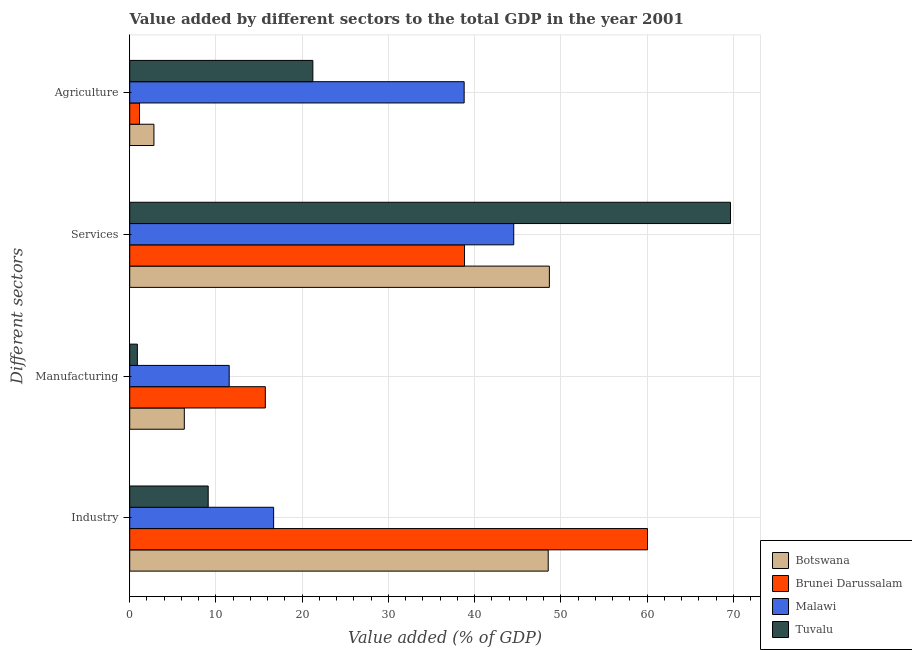How many different coloured bars are there?
Offer a very short reply. 4. How many groups of bars are there?
Ensure brevity in your answer.  4. What is the label of the 1st group of bars from the top?
Offer a very short reply. Agriculture. What is the value added by industrial sector in Tuvalu?
Your answer should be compact. 9.1. Across all countries, what is the maximum value added by agricultural sector?
Your answer should be compact. 38.78. Across all countries, what is the minimum value added by manufacturing sector?
Ensure brevity in your answer.  0.89. In which country was the value added by agricultural sector maximum?
Offer a very short reply. Malawi. In which country was the value added by manufacturing sector minimum?
Keep it short and to the point. Tuvalu. What is the total value added by services sector in the graph?
Keep it short and to the point. 201.68. What is the difference between the value added by services sector in Tuvalu and that in Brunei Darussalam?
Ensure brevity in your answer.  30.84. What is the difference between the value added by services sector in Botswana and the value added by agricultural sector in Brunei Darussalam?
Offer a very short reply. 47.53. What is the average value added by services sector per country?
Offer a terse response. 50.42. What is the difference between the value added by manufacturing sector and value added by services sector in Brunei Darussalam?
Your answer should be compact. -23.1. What is the ratio of the value added by services sector in Malawi to that in Tuvalu?
Offer a very short reply. 0.64. Is the difference between the value added by agricultural sector in Malawi and Tuvalu greater than the difference between the value added by industrial sector in Malawi and Tuvalu?
Make the answer very short. Yes. What is the difference between the highest and the second highest value added by manufacturing sector?
Your answer should be very brief. 4.19. What is the difference between the highest and the lowest value added by agricultural sector?
Provide a succinct answer. 37.65. In how many countries, is the value added by industrial sector greater than the average value added by industrial sector taken over all countries?
Give a very brief answer. 2. What does the 1st bar from the top in Industry represents?
Give a very brief answer. Tuvalu. What does the 1st bar from the bottom in Agriculture represents?
Give a very brief answer. Botswana. How many countries are there in the graph?
Provide a short and direct response. 4. Are the values on the major ticks of X-axis written in scientific E-notation?
Your answer should be very brief. No. Where does the legend appear in the graph?
Your answer should be compact. Bottom right. How many legend labels are there?
Your answer should be very brief. 4. How are the legend labels stacked?
Your response must be concise. Vertical. What is the title of the graph?
Keep it short and to the point. Value added by different sectors to the total GDP in the year 2001. What is the label or title of the X-axis?
Provide a succinct answer. Value added (% of GDP). What is the label or title of the Y-axis?
Your response must be concise. Different sectors. What is the Value added (% of GDP) in Botswana in Industry?
Make the answer very short. 48.53. What is the Value added (% of GDP) of Brunei Darussalam in Industry?
Provide a succinct answer. 60.04. What is the Value added (% of GDP) in Malawi in Industry?
Make the answer very short. 16.69. What is the Value added (% of GDP) in Tuvalu in Industry?
Make the answer very short. 9.1. What is the Value added (% of GDP) of Botswana in Manufacturing?
Your response must be concise. 6.33. What is the Value added (% of GDP) of Brunei Darussalam in Manufacturing?
Make the answer very short. 15.73. What is the Value added (% of GDP) in Malawi in Manufacturing?
Offer a very short reply. 11.53. What is the Value added (% of GDP) in Tuvalu in Manufacturing?
Give a very brief answer. 0.89. What is the Value added (% of GDP) in Botswana in Services?
Your answer should be very brief. 48.66. What is the Value added (% of GDP) of Brunei Darussalam in Services?
Give a very brief answer. 38.82. What is the Value added (% of GDP) in Malawi in Services?
Your response must be concise. 44.53. What is the Value added (% of GDP) of Tuvalu in Services?
Offer a terse response. 69.66. What is the Value added (% of GDP) of Botswana in Agriculture?
Make the answer very short. 2.81. What is the Value added (% of GDP) of Brunei Darussalam in Agriculture?
Offer a terse response. 1.13. What is the Value added (% of GDP) of Malawi in Agriculture?
Offer a terse response. 38.78. What is the Value added (% of GDP) of Tuvalu in Agriculture?
Provide a short and direct response. 21.24. Across all Different sectors, what is the maximum Value added (% of GDP) of Botswana?
Make the answer very short. 48.66. Across all Different sectors, what is the maximum Value added (% of GDP) in Brunei Darussalam?
Ensure brevity in your answer.  60.04. Across all Different sectors, what is the maximum Value added (% of GDP) in Malawi?
Your answer should be very brief. 44.53. Across all Different sectors, what is the maximum Value added (% of GDP) of Tuvalu?
Make the answer very short. 69.66. Across all Different sectors, what is the minimum Value added (% of GDP) of Botswana?
Your response must be concise. 2.81. Across all Different sectors, what is the minimum Value added (% of GDP) in Brunei Darussalam?
Ensure brevity in your answer.  1.13. Across all Different sectors, what is the minimum Value added (% of GDP) of Malawi?
Your response must be concise. 11.53. Across all Different sectors, what is the minimum Value added (% of GDP) in Tuvalu?
Your response must be concise. 0.89. What is the total Value added (% of GDP) in Botswana in the graph?
Provide a succinct answer. 106.33. What is the total Value added (% of GDP) of Brunei Darussalam in the graph?
Offer a terse response. 115.73. What is the total Value added (% of GDP) of Malawi in the graph?
Ensure brevity in your answer.  111.53. What is the total Value added (% of GDP) of Tuvalu in the graph?
Keep it short and to the point. 100.89. What is the difference between the Value added (% of GDP) in Botswana in Industry and that in Manufacturing?
Keep it short and to the point. 42.2. What is the difference between the Value added (% of GDP) of Brunei Darussalam in Industry and that in Manufacturing?
Your response must be concise. 44.32. What is the difference between the Value added (% of GDP) of Malawi in Industry and that in Manufacturing?
Make the answer very short. 5.15. What is the difference between the Value added (% of GDP) of Tuvalu in Industry and that in Manufacturing?
Offer a terse response. 8.21. What is the difference between the Value added (% of GDP) of Botswana in Industry and that in Services?
Give a very brief answer. -0.13. What is the difference between the Value added (% of GDP) of Brunei Darussalam in Industry and that in Services?
Keep it short and to the point. 21.22. What is the difference between the Value added (% of GDP) of Malawi in Industry and that in Services?
Provide a short and direct response. -27.84. What is the difference between the Value added (% of GDP) of Tuvalu in Industry and that in Services?
Make the answer very short. -60.56. What is the difference between the Value added (% of GDP) of Botswana in Industry and that in Agriculture?
Your response must be concise. 45.72. What is the difference between the Value added (% of GDP) of Brunei Darussalam in Industry and that in Agriculture?
Give a very brief answer. 58.91. What is the difference between the Value added (% of GDP) in Malawi in Industry and that in Agriculture?
Offer a very short reply. -22.09. What is the difference between the Value added (% of GDP) of Tuvalu in Industry and that in Agriculture?
Give a very brief answer. -12.14. What is the difference between the Value added (% of GDP) in Botswana in Manufacturing and that in Services?
Your response must be concise. -42.33. What is the difference between the Value added (% of GDP) of Brunei Darussalam in Manufacturing and that in Services?
Your answer should be compact. -23.1. What is the difference between the Value added (% of GDP) in Malawi in Manufacturing and that in Services?
Make the answer very short. -33. What is the difference between the Value added (% of GDP) in Tuvalu in Manufacturing and that in Services?
Your response must be concise. -68.78. What is the difference between the Value added (% of GDP) of Botswana in Manufacturing and that in Agriculture?
Provide a succinct answer. 3.52. What is the difference between the Value added (% of GDP) in Brunei Darussalam in Manufacturing and that in Agriculture?
Offer a very short reply. 14.59. What is the difference between the Value added (% of GDP) of Malawi in Manufacturing and that in Agriculture?
Your answer should be compact. -27.25. What is the difference between the Value added (% of GDP) of Tuvalu in Manufacturing and that in Agriculture?
Provide a short and direct response. -20.35. What is the difference between the Value added (% of GDP) of Botswana in Services and that in Agriculture?
Ensure brevity in your answer.  45.86. What is the difference between the Value added (% of GDP) of Brunei Darussalam in Services and that in Agriculture?
Ensure brevity in your answer.  37.69. What is the difference between the Value added (% of GDP) of Malawi in Services and that in Agriculture?
Give a very brief answer. 5.75. What is the difference between the Value added (% of GDP) in Tuvalu in Services and that in Agriculture?
Your answer should be very brief. 48.43. What is the difference between the Value added (% of GDP) in Botswana in Industry and the Value added (% of GDP) in Brunei Darussalam in Manufacturing?
Ensure brevity in your answer.  32.8. What is the difference between the Value added (% of GDP) of Botswana in Industry and the Value added (% of GDP) of Malawi in Manufacturing?
Your response must be concise. 36.99. What is the difference between the Value added (% of GDP) of Botswana in Industry and the Value added (% of GDP) of Tuvalu in Manufacturing?
Give a very brief answer. 47.64. What is the difference between the Value added (% of GDP) of Brunei Darussalam in Industry and the Value added (% of GDP) of Malawi in Manufacturing?
Your answer should be very brief. 48.51. What is the difference between the Value added (% of GDP) in Brunei Darussalam in Industry and the Value added (% of GDP) in Tuvalu in Manufacturing?
Offer a very short reply. 59.16. What is the difference between the Value added (% of GDP) in Malawi in Industry and the Value added (% of GDP) in Tuvalu in Manufacturing?
Offer a terse response. 15.8. What is the difference between the Value added (% of GDP) of Botswana in Industry and the Value added (% of GDP) of Brunei Darussalam in Services?
Make the answer very short. 9.71. What is the difference between the Value added (% of GDP) in Botswana in Industry and the Value added (% of GDP) in Malawi in Services?
Give a very brief answer. 4. What is the difference between the Value added (% of GDP) of Botswana in Industry and the Value added (% of GDP) of Tuvalu in Services?
Keep it short and to the point. -21.14. What is the difference between the Value added (% of GDP) of Brunei Darussalam in Industry and the Value added (% of GDP) of Malawi in Services?
Your response must be concise. 15.51. What is the difference between the Value added (% of GDP) in Brunei Darussalam in Industry and the Value added (% of GDP) in Tuvalu in Services?
Provide a short and direct response. -9.62. What is the difference between the Value added (% of GDP) in Malawi in Industry and the Value added (% of GDP) in Tuvalu in Services?
Keep it short and to the point. -52.98. What is the difference between the Value added (% of GDP) of Botswana in Industry and the Value added (% of GDP) of Brunei Darussalam in Agriculture?
Your response must be concise. 47.39. What is the difference between the Value added (% of GDP) of Botswana in Industry and the Value added (% of GDP) of Malawi in Agriculture?
Offer a very short reply. 9.75. What is the difference between the Value added (% of GDP) of Botswana in Industry and the Value added (% of GDP) of Tuvalu in Agriculture?
Give a very brief answer. 27.29. What is the difference between the Value added (% of GDP) of Brunei Darussalam in Industry and the Value added (% of GDP) of Malawi in Agriculture?
Provide a short and direct response. 21.26. What is the difference between the Value added (% of GDP) of Brunei Darussalam in Industry and the Value added (% of GDP) of Tuvalu in Agriculture?
Your answer should be very brief. 38.81. What is the difference between the Value added (% of GDP) of Malawi in Industry and the Value added (% of GDP) of Tuvalu in Agriculture?
Provide a short and direct response. -4.55. What is the difference between the Value added (% of GDP) of Botswana in Manufacturing and the Value added (% of GDP) of Brunei Darussalam in Services?
Make the answer very short. -32.49. What is the difference between the Value added (% of GDP) in Botswana in Manufacturing and the Value added (% of GDP) in Malawi in Services?
Make the answer very short. -38.2. What is the difference between the Value added (% of GDP) in Botswana in Manufacturing and the Value added (% of GDP) in Tuvalu in Services?
Provide a succinct answer. -63.33. What is the difference between the Value added (% of GDP) of Brunei Darussalam in Manufacturing and the Value added (% of GDP) of Malawi in Services?
Provide a short and direct response. -28.8. What is the difference between the Value added (% of GDP) of Brunei Darussalam in Manufacturing and the Value added (% of GDP) of Tuvalu in Services?
Give a very brief answer. -53.94. What is the difference between the Value added (% of GDP) in Malawi in Manufacturing and the Value added (% of GDP) in Tuvalu in Services?
Keep it short and to the point. -58.13. What is the difference between the Value added (% of GDP) of Botswana in Manufacturing and the Value added (% of GDP) of Brunei Darussalam in Agriculture?
Ensure brevity in your answer.  5.2. What is the difference between the Value added (% of GDP) in Botswana in Manufacturing and the Value added (% of GDP) in Malawi in Agriculture?
Make the answer very short. -32.45. What is the difference between the Value added (% of GDP) of Botswana in Manufacturing and the Value added (% of GDP) of Tuvalu in Agriculture?
Make the answer very short. -14.91. What is the difference between the Value added (% of GDP) of Brunei Darussalam in Manufacturing and the Value added (% of GDP) of Malawi in Agriculture?
Give a very brief answer. -23.06. What is the difference between the Value added (% of GDP) of Brunei Darussalam in Manufacturing and the Value added (% of GDP) of Tuvalu in Agriculture?
Provide a succinct answer. -5.51. What is the difference between the Value added (% of GDP) of Malawi in Manufacturing and the Value added (% of GDP) of Tuvalu in Agriculture?
Offer a very short reply. -9.7. What is the difference between the Value added (% of GDP) of Botswana in Services and the Value added (% of GDP) of Brunei Darussalam in Agriculture?
Provide a short and direct response. 47.53. What is the difference between the Value added (% of GDP) in Botswana in Services and the Value added (% of GDP) in Malawi in Agriculture?
Offer a terse response. 9.88. What is the difference between the Value added (% of GDP) of Botswana in Services and the Value added (% of GDP) of Tuvalu in Agriculture?
Keep it short and to the point. 27.43. What is the difference between the Value added (% of GDP) of Brunei Darussalam in Services and the Value added (% of GDP) of Malawi in Agriculture?
Provide a short and direct response. 0.04. What is the difference between the Value added (% of GDP) of Brunei Darussalam in Services and the Value added (% of GDP) of Tuvalu in Agriculture?
Provide a succinct answer. 17.59. What is the difference between the Value added (% of GDP) in Malawi in Services and the Value added (% of GDP) in Tuvalu in Agriculture?
Make the answer very short. 23.29. What is the average Value added (% of GDP) in Botswana per Different sectors?
Offer a terse response. 26.58. What is the average Value added (% of GDP) in Brunei Darussalam per Different sectors?
Your answer should be compact. 28.93. What is the average Value added (% of GDP) in Malawi per Different sectors?
Offer a very short reply. 27.88. What is the average Value added (% of GDP) of Tuvalu per Different sectors?
Ensure brevity in your answer.  25.22. What is the difference between the Value added (% of GDP) of Botswana and Value added (% of GDP) of Brunei Darussalam in Industry?
Your response must be concise. -11.51. What is the difference between the Value added (% of GDP) in Botswana and Value added (% of GDP) in Malawi in Industry?
Offer a very short reply. 31.84. What is the difference between the Value added (% of GDP) of Botswana and Value added (% of GDP) of Tuvalu in Industry?
Your answer should be very brief. 39.43. What is the difference between the Value added (% of GDP) in Brunei Darussalam and Value added (% of GDP) in Malawi in Industry?
Offer a terse response. 43.35. What is the difference between the Value added (% of GDP) of Brunei Darussalam and Value added (% of GDP) of Tuvalu in Industry?
Provide a succinct answer. 50.94. What is the difference between the Value added (% of GDP) of Malawi and Value added (% of GDP) of Tuvalu in Industry?
Your answer should be compact. 7.59. What is the difference between the Value added (% of GDP) in Botswana and Value added (% of GDP) in Brunei Darussalam in Manufacturing?
Your answer should be compact. -9.39. What is the difference between the Value added (% of GDP) in Botswana and Value added (% of GDP) in Malawi in Manufacturing?
Provide a succinct answer. -5.2. What is the difference between the Value added (% of GDP) of Botswana and Value added (% of GDP) of Tuvalu in Manufacturing?
Give a very brief answer. 5.45. What is the difference between the Value added (% of GDP) in Brunei Darussalam and Value added (% of GDP) in Malawi in Manufacturing?
Ensure brevity in your answer.  4.19. What is the difference between the Value added (% of GDP) in Brunei Darussalam and Value added (% of GDP) in Tuvalu in Manufacturing?
Ensure brevity in your answer.  14.84. What is the difference between the Value added (% of GDP) in Malawi and Value added (% of GDP) in Tuvalu in Manufacturing?
Ensure brevity in your answer.  10.65. What is the difference between the Value added (% of GDP) in Botswana and Value added (% of GDP) in Brunei Darussalam in Services?
Your response must be concise. 9.84. What is the difference between the Value added (% of GDP) in Botswana and Value added (% of GDP) in Malawi in Services?
Ensure brevity in your answer.  4.13. What is the difference between the Value added (% of GDP) of Botswana and Value added (% of GDP) of Tuvalu in Services?
Provide a short and direct response. -21. What is the difference between the Value added (% of GDP) in Brunei Darussalam and Value added (% of GDP) in Malawi in Services?
Make the answer very short. -5.71. What is the difference between the Value added (% of GDP) in Brunei Darussalam and Value added (% of GDP) in Tuvalu in Services?
Offer a terse response. -30.84. What is the difference between the Value added (% of GDP) of Malawi and Value added (% of GDP) of Tuvalu in Services?
Make the answer very short. -25.13. What is the difference between the Value added (% of GDP) in Botswana and Value added (% of GDP) in Brunei Darussalam in Agriculture?
Offer a terse response. 1.67. What is the difference between the Value added (% of GDP) in Botswana and Value added (% of GDP) in Malawi in Agriculture?
Offer a terse response. -35.97. What is the difference between the Value added (% of GDP) in Botswana and Value added (% of GDP) in Tuvalu in Agriculture?
Give a very brief answer. -18.43. What is the difference between the Value added (% of GDP) in Brunei Darussalam and Value added (% of GDP) in Malawi in Agriculture?
Your answer should be compact. -37.65. What is the difference between the Value added (% of GDP) in Brunei Darussalam and Value added (% of GDP) in Tuvalu in Agriculture?
Ensure brevity in your answer.  -20.1. What is the difference between the Value added (% of GDP) in Malawi and Value added (% of GDP) in Tuvalu in Agriculture?
Your answer should be very brief. 17.55. What is the ratio of the Value added (% of GDP) in Botswana in Industry to that in Manufacturing?
Ensure brevity in your answer.  7.67. What is the ratio of the Value added (% of GDP) of Brunei Darussalam in Industry to that in Manufacturing?
Your response must be concise. 3.82. What is the ratio of the Value added (% of GDP) in Malawi in Industry to that in Manufacturing?
Your response must be concise. 1.45. What is the ratio of the Value added (% of GDP) of Tuvalu in Industry to that in Manufacturing?
Ensure brevity in your answer.  10.28. What is the ratio of the Value added (% of GDP) in Brunei Darussalam in Industry to that in Services?
Give a very brief answer. 1.55. What is the ratio of the Value added (% of GDP) in Malawi in Industry to that in Services?
Your response must be concise. 0.37. What is the ratio of the Value added (% of GDP) in Tuvalu in Industry to that in Services?
Provide a succinct answer. 0.13. What is the ratio of the Value added (% of GDP) of Botswana in Industry to that in Agriculture?
Ensure brevity in your answer.  17.28. What is the ratio of the Value added (% of GDP) of Brunei Darussalam in Industry to that in Agriculture?
Your answer should be very brief. 52.92. What is the ratio of the Value added (% of GDP) in Malawi in Industry to that in Agriculture?
Your answer should be compact. 0.43. What is the ratio of the Value added (% of GDP) in Tuvalu in Industry to that in Agriculture?
Make the answer very short. 0.43. What is the ratio of the Value added (% of GDP) in Botswana in Manufacturing to that in Services?
Your answer should be very brief. 0.13. What is the ratio of the Value added (% of GDP) in Brunei Darussalam in Manufacturing to that in Services?
Your answer should be compact. 0.41. What is the ratio of the Value added (% of GDP) in Malawi in Manufacturing to that in Services?
Your answer should be very brief. 0.26. What is the ratio of the Value added (% of GDP) of Tuvalu in Manufacturing to that in Services?
Provide a short and direct response. 0.01. What is the ratio of the Value added (% of GDP) of Botswana in Manufacturing to that in Agriculture?
Ensure brevity in your answer.  2.25. What is the ratio of the Value added (% of GDP) of Brunei Darussalam in Manufacturing to that in Agriculture?
Keep it short and to the point. 13.86. What is the ratio of the Value added (% of GDP) of Malawi in Manufacturing to that in Agriculture?
Make the answer very short. 0.3. What is the ratio of the Value added (% of GDP) in Tuvalu in Manufacturing to that in Agriculture?
Your response must be concise. 0.04. What is the ratio of the Value added (% of GDP) in Botswana in Services to that in Agriculture?
Give a very brief answer. 17.33. What is the ratio of the Value added (% of GDP) of Brunei Darussalam in Services to that in Agriculture?
Your answer should be compact. 34.22. What is the ratio of the Value added (% of GDP) of Malawi in Services to that in Agriculture?
Keep it short and to the point. 1.15. What is the ratio of the Value added (% of GDP) in Tuvalu in Services to that in Agriculture?
Keep it short and to the point. 3.28. What is the difference between the highest and the second highest Value added (% of GDP) of Botswana?
Provide a succinct answer. 0.13. What is the difference between the highest and the second highest Value added (% of GDP) in Brunei Darussalam?
Offer a very short reply. 21.22. What is the difference between the highest and the second highest Value added (% of GDP) of Malawi?
Your answer should be very brief. 5.75. What is the difference between the highest and the second highest Value added (% of GDP) in Tuvalu?
Give a very brief answer. 48.43. What is the difference between the highest and the lowest Value added (% of GDP) in Botswana?
Provide a succinct answer. 45.86. What is the difference between the highest and the lowest Value added (% of GDP) of Brunei Darussalam?
Provide a short and direct response. 58.91. What is the difference between the highest and the lowest Value added (% of GDP) in Malawi?
Offer a very short reply. 33. What is the difference between the highest and the lowest Value added (% of GDP) in Tuvalu?
Provide a succinct answer. 68.78. 